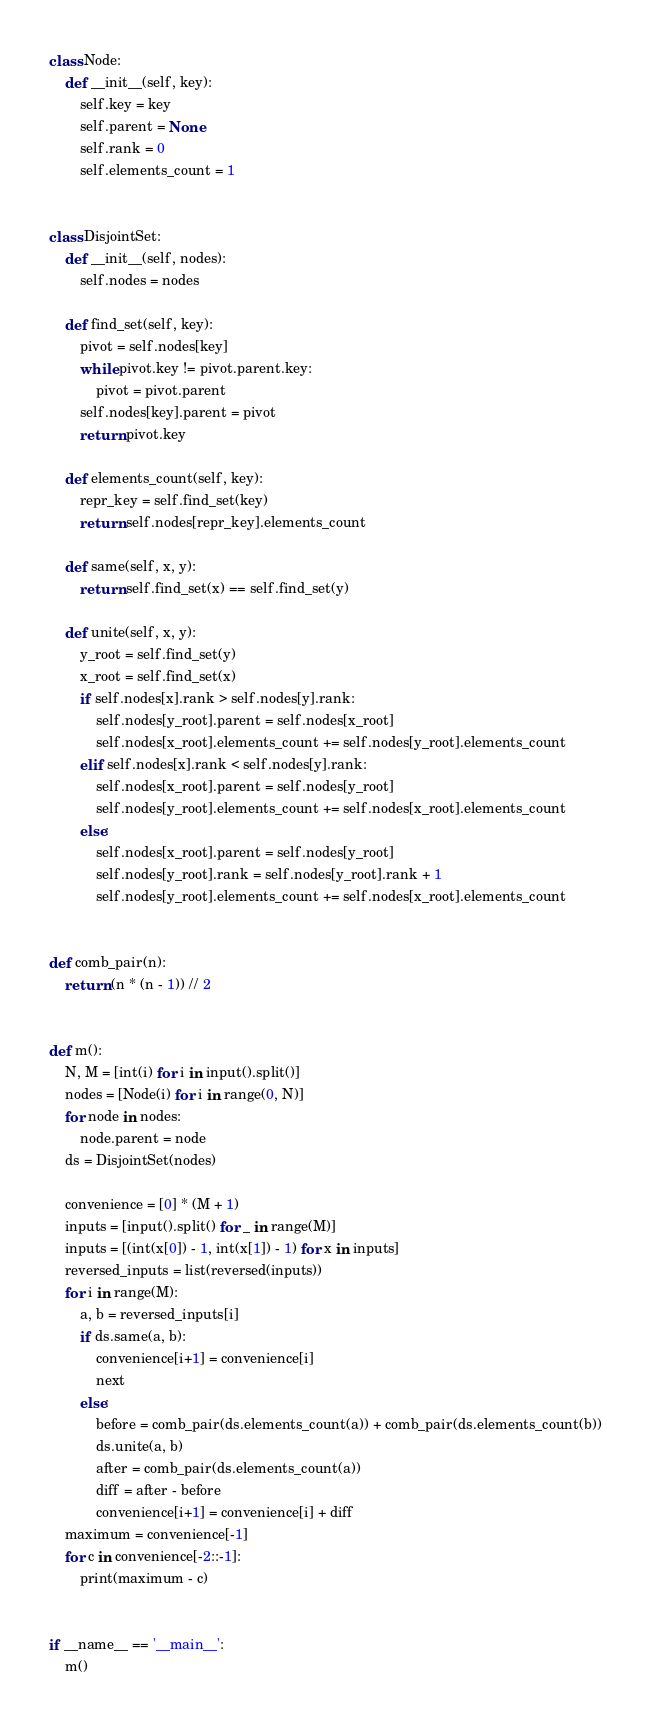Convert code to text. <code><loc_0><loc_0><loc_500><loc_500><_Python_>
class Node:
    def __init__(self, key):
        self.key = key
        self.parent = None
        self.rank = 0
        self.elements_count = 1


class DisjointSet:
    def __init__(self, nodes):
        self.nodes = nodes

    def find_set(self, key):
        pivot = self.nodes[key]
        while pivot.key != pivot.parent.key:
            pivot = pivot.parent
        self.nodes[key].parent = pivot
        return pivot.key

    def elements_count(self, key):
        repr_key = self.find_set(key)
        return self.nodes[repr_key].elements_count

    def same(self, x, y):
        return self.find_set(x) == self.find_set(y)

    def unite(self, x, y):
        y_root = self.find_set(y)
        x_root = self.find_set(x)
        if self.nodes[x].rank > self.nodes[y].rank:
            self.nodes[y_root].parent = self.nodes[x_root]
            self.nodes[x_root].elements_count += self.nodes[y_root].elements_count
        elif self.nodes[x].rank < self.nodes[y].rank:
            self.nodes[x_root].parent = self.nodes[y_root]
            self.nodes[y_root].elements_count += self.nodes[x_root].elements_count
        else:
            self.nodes[x_root].parent = self.nodes[y_root]
            self.nodes[y_root].rank = self.nodes[y_root].rank + 1
            self.nodes[y_root].elements_count += self.nodes[x_root].elements_count


def comb_pair(n):
    return (n * (n - 1)) // 2


def m():
    N, M = [int(i) for i in input().split()]
    nodes = [Node(i) for i in range(0, N)]
    for node in nodes:
        node.parent = node
    ds = DisjointSet(nodes)

    convenience = [0] * (M + 1)
    inputs = [input().split() for _ in range(M)]
    inputs = [(int(x[0]) - 1, int(x[1]) - 1) for x in inputs]
    reversed_inputs = list(reversed(inputs))
    for i in range(M):
        a, b = reversed_inputs[i]
        if ds.same(a, b):
            convenience[i+1] = convenience[i]
            next
        else:
            before = comb_pair(ds.elements_count(a)) + comb_pair(ds.elements_count(b))
            ds.unite(a, b)
            after = comb_pair(ds.elements_count(a))
            diff = after - before
            convenience[i+1] = convenience[i] + diff
    maximum = convenience[-1]
    for c in convenience[-2::-1]:
        print(maximum - c)


if __name__ == '__main__':
    m()
</code> 